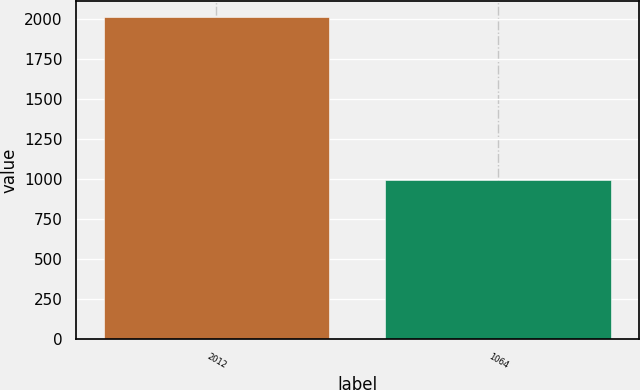Convert chart. <chart><loc_0><loc_0><loc_500><loc_500><bar_chart><fcel>2012<fcel>1064<nl><fcel>2010<fcel>995<nl></chart> 